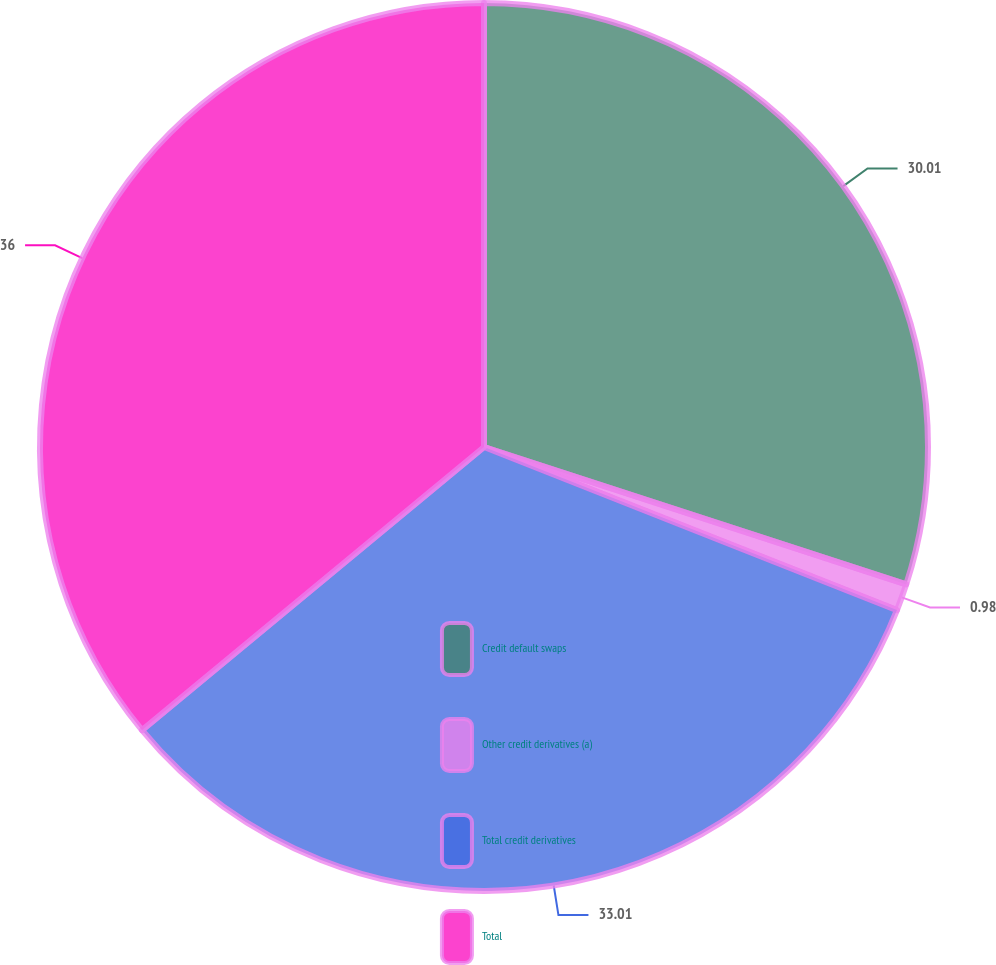<chart> <loc_0><loc_0><loc_500><loc_500><pie_chart><fcel>Credit default swaps<fcel>Other credit derivatives (a)<fcel>Total credit derivatives<fcel>Total<nl><fcel>30.01%<fcel>0.98%<fcel>33.01%<fcel>36.01%<nl></chart> 